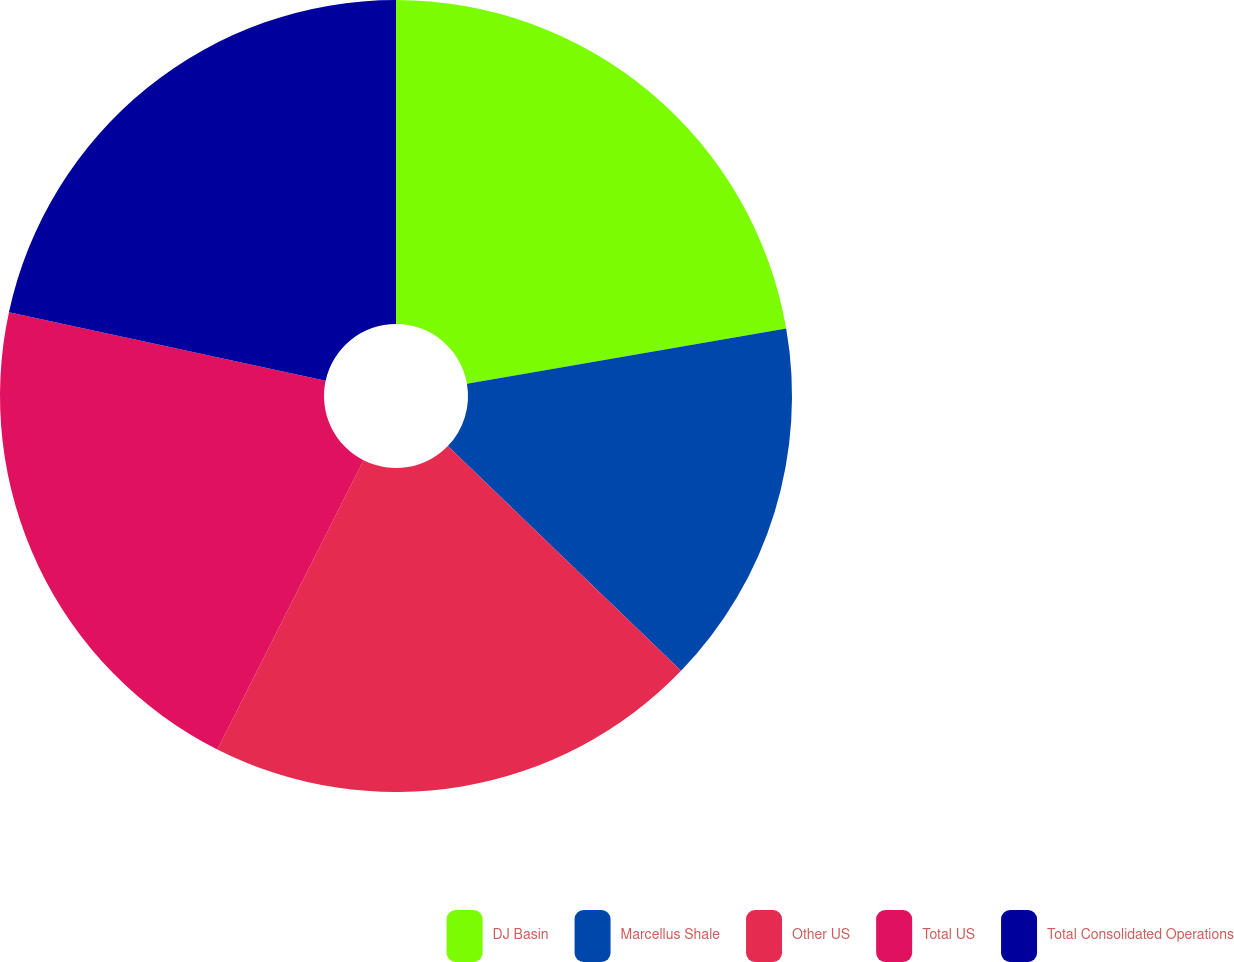Convert chart to OTSL. <chart><loc_0><loc_0><loc_500><loc_500><pie_chart><fcel>DJ Basin<fcel>Marcellus Shale<fcel>Other US<fcel>Total US<fcel>Total Consolidated Operations<nl><fcel>22.27%<fcel>14.94%<fcel>20.24%<fcel>20.94%<fcel>21.61%<nl></chart> 